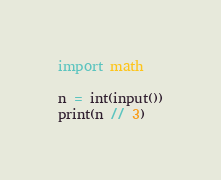<code> <loc_0><loc_0><loc_500><loc_500><_Python_>import math

n = int(input())
print(n // 3)</code> 